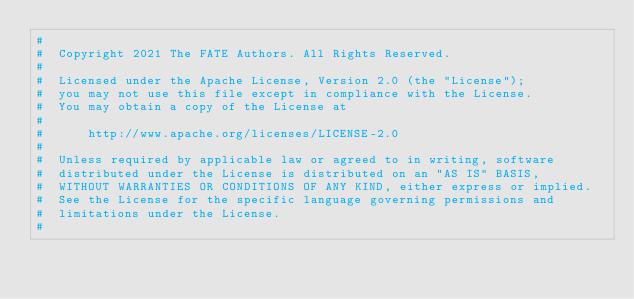Convert code to text. <code><loc_0><loc_0><loc_500><loc_500><_Python_>#
#  Copyright 2021 The FATE Authors. All Rights Reserved.
#
#  Licensed under the Apache License, Version 2.0 (the "License");
#  you may not use this file except in compliance with the License.
#  You may obtain a copy of the License at
#
#      http://www.apache.org/licenses/LICENSE-2.0
#
#  Unless required by applicable law or agreed to in writing, software
#  distributed under the License is distributed on an "AS IS" BASIS,
#  WITHOUT WARRANTIES OR CONDITIONS OF ANY KIND, either express or implied.
#  See the License for the specific language governing permissions and
#  limitations under the License.
#
</code> 